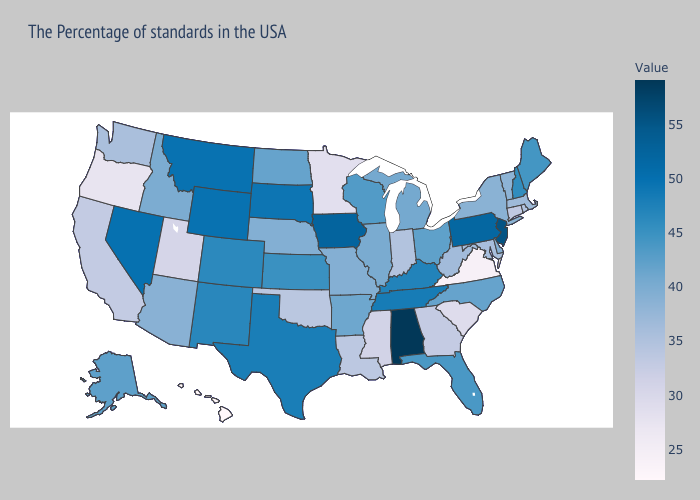Does Alabama have the highest value in the South?
Quick response, please. Yes. Does the map have missing data?
Answer briefly. No. Which states hav the highest value in the South?
Concise answer only. Alabama. 